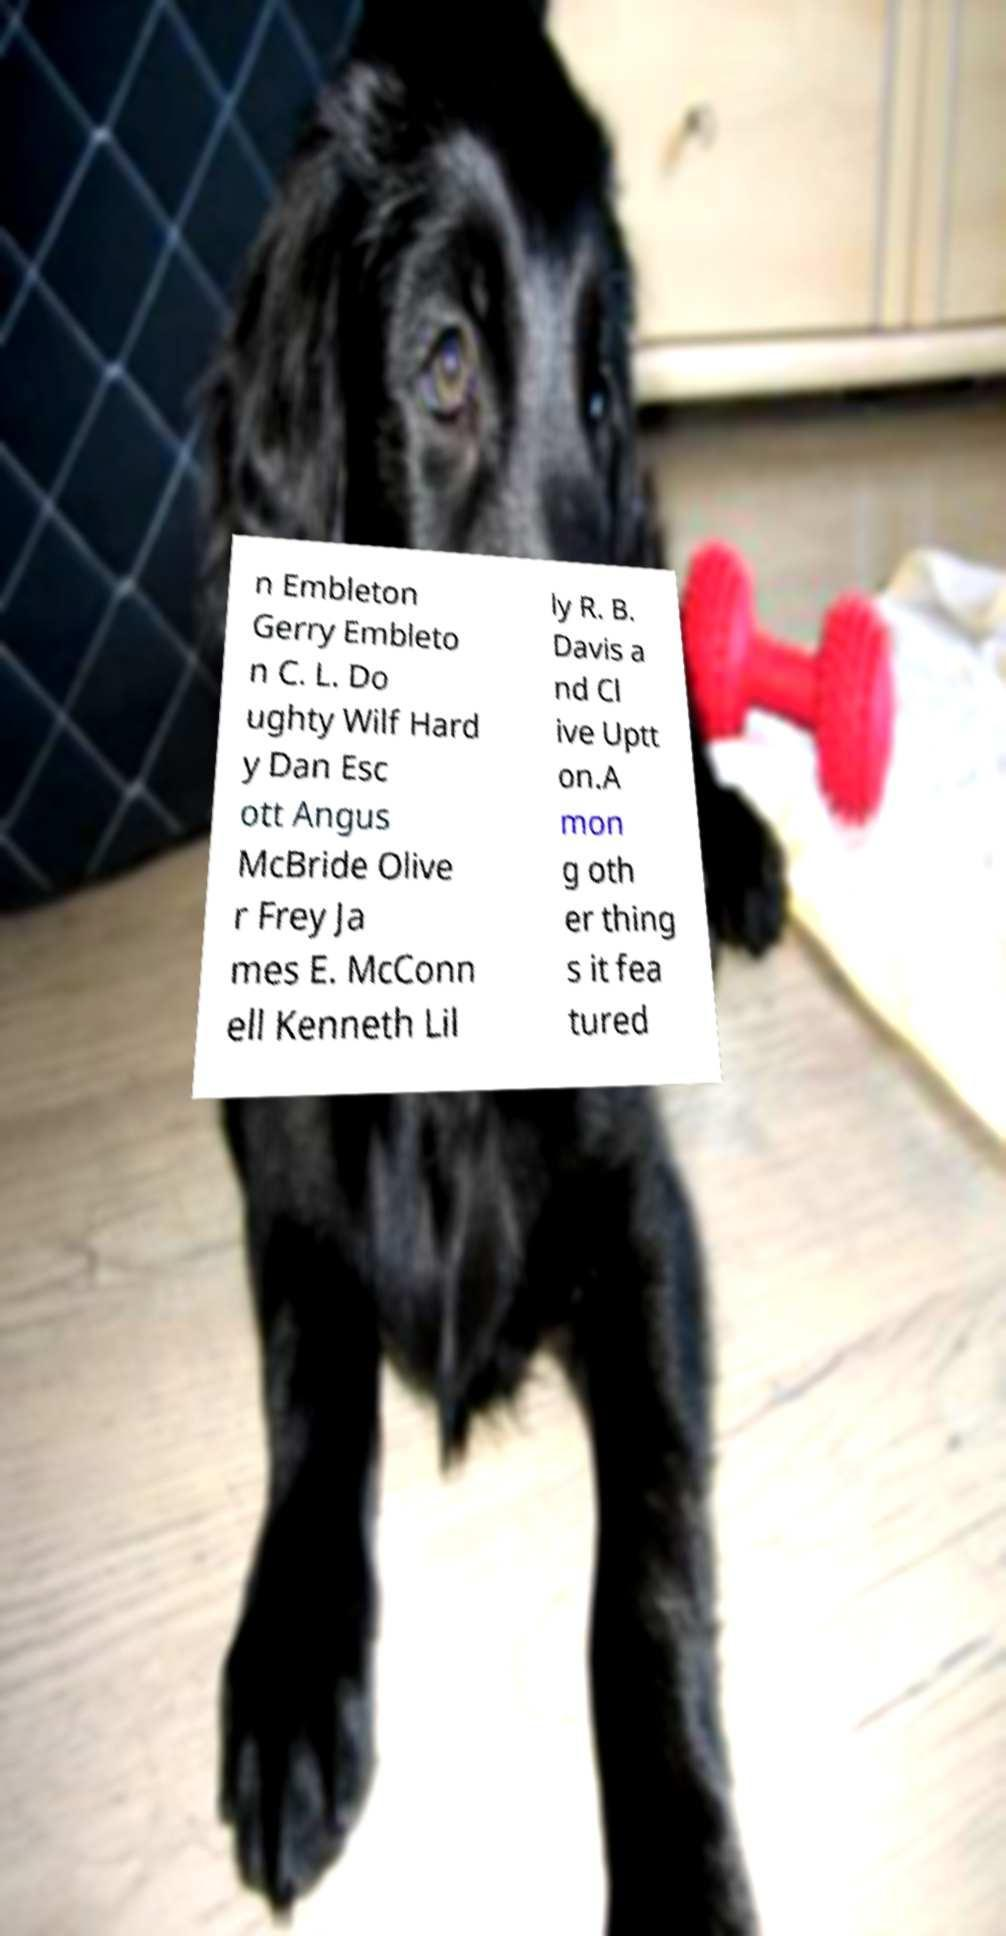Please identify and transcribe the text found in this image. n Embleton Gerry Embleto n C. L. Do ughty Wilf Hard y Dan Esc ott Angus McBride Olive r Frey Ja mes E. McConn ell Kenneth Lil ly R. B. Davis a nd Cl ive Uptt on.A mon g oth er thing s it fea tured 